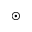<formula> <loc_0><loc_0><loc_500><loc_500>\odot</formula> 